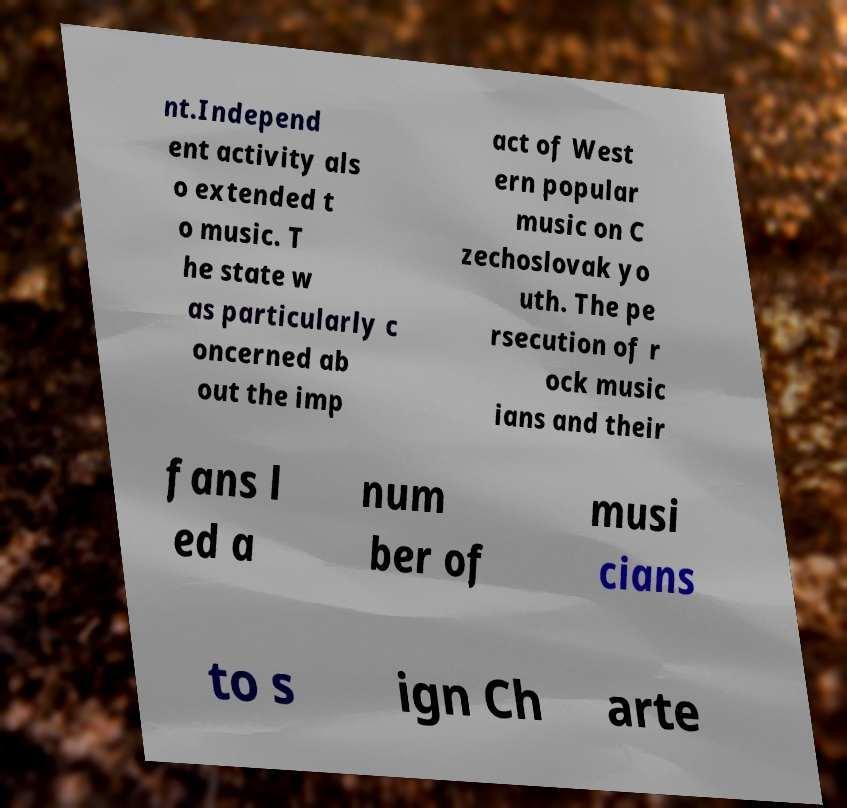Could you extract and type out the text from this image? nt.Independ ent activity als o extended t o music. T he state w as particularly c oncerned ab out the imp act of West ern popular music on C zechoslovak yo uth. The pe rsecution of r ock music ians and their fans l ed a num ber of musi cians to s ign Ch arte 